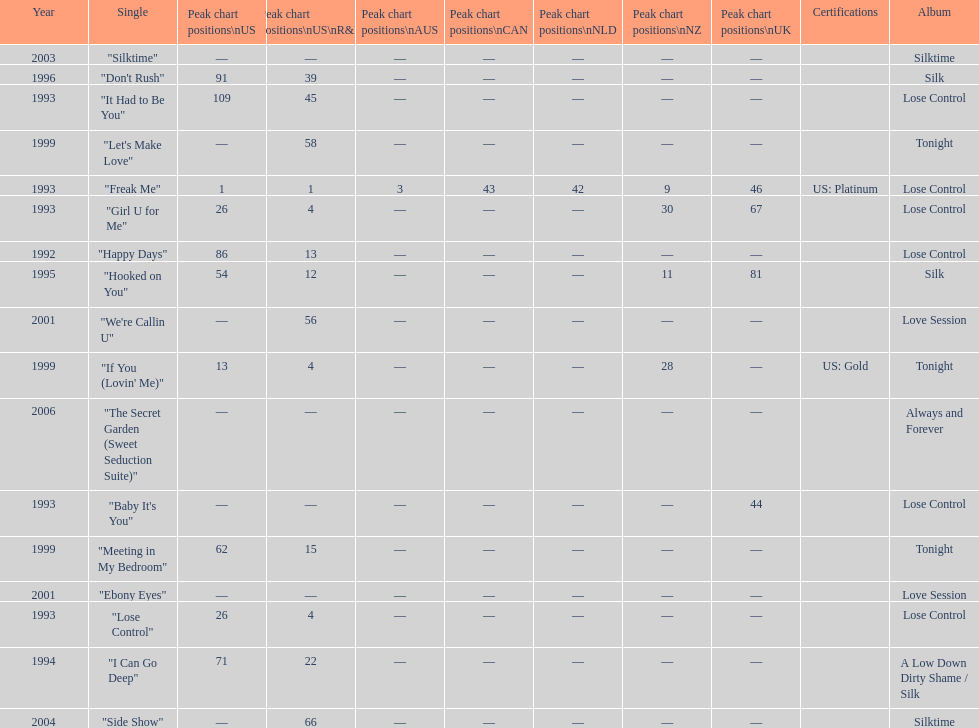Which single is the most in terms of how many times it charted? "Freak Me". 